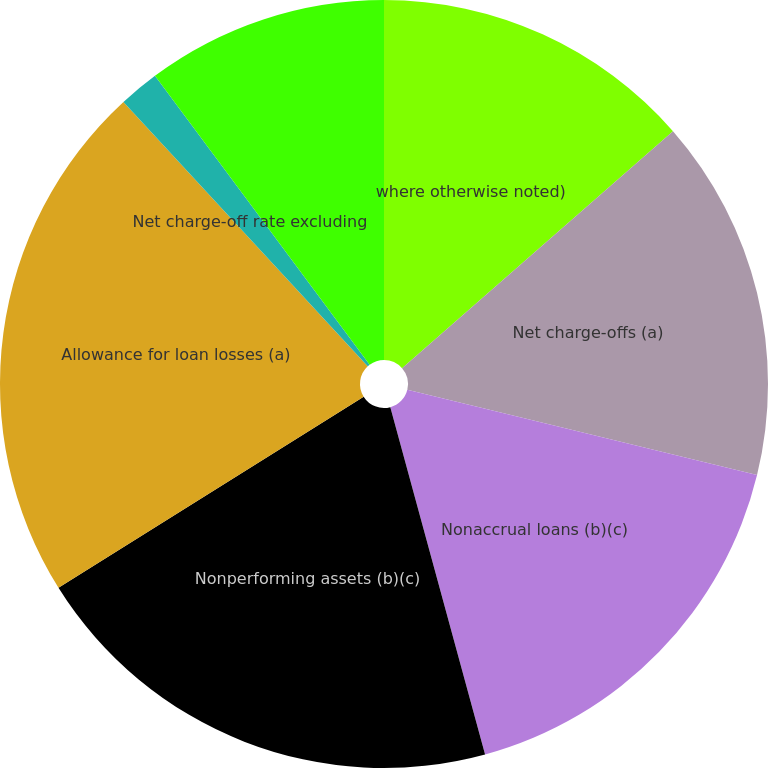<chart> <loc_0><loc_0><loc_500><loc_500><pie_chart><fcel>where otherwise noted)<fcel>Net charge-offs (a)<fcel>Nonaccrual loans (b)(c)<fcel>Nonperforming assets (b)(c)<fcel>Allowance for loan losses (a)<fcel>Net charge-off rate (a)<fcel>Net charge-off rate excluding<fcel>Allowance for loan losses to<nl><fcel>13.56%<fcel>15.25%<fcel>16.95%<fcel>20.34%<fcel>22.03%<fcel>0.0%<fcel>1.7%<fcel>10.17%<nl></chart> 